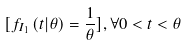<formula> <loc_0><loc_0><loc_500><loc_500>[ f _ { I _ { 1 } } \left ( t | \theta \right ) = \frac { 1 } { \theta } ] , \forall 0 < t < \theta</formula> 